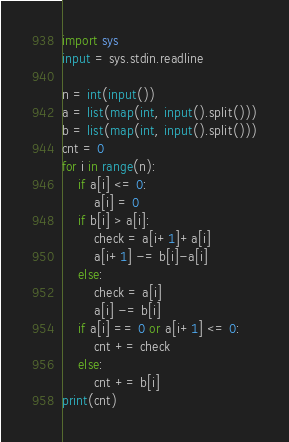<code> <loc_0><loc_0><loc_500><loc_500><_Python_>import sys
input = sys.stdin.readline

n = int(input())
a = list(map(int, input().split()))
b = list(map(int, input().split()))
cnt = 0
for i in range(n):
    if a[i] <= 0:
        a[i] = 0
    if b[i] > a[i]:
        check = a[i+1]+a[i]
        a[i+1] -= b[i]-a[i]
    else:
        check = a[i]
        a[i] -= b[i]
    if a[i] == 0 or a[i+1] <= 0:
        cnt += check
    else:
        cnt += b[i]
print(cnt)</code> 